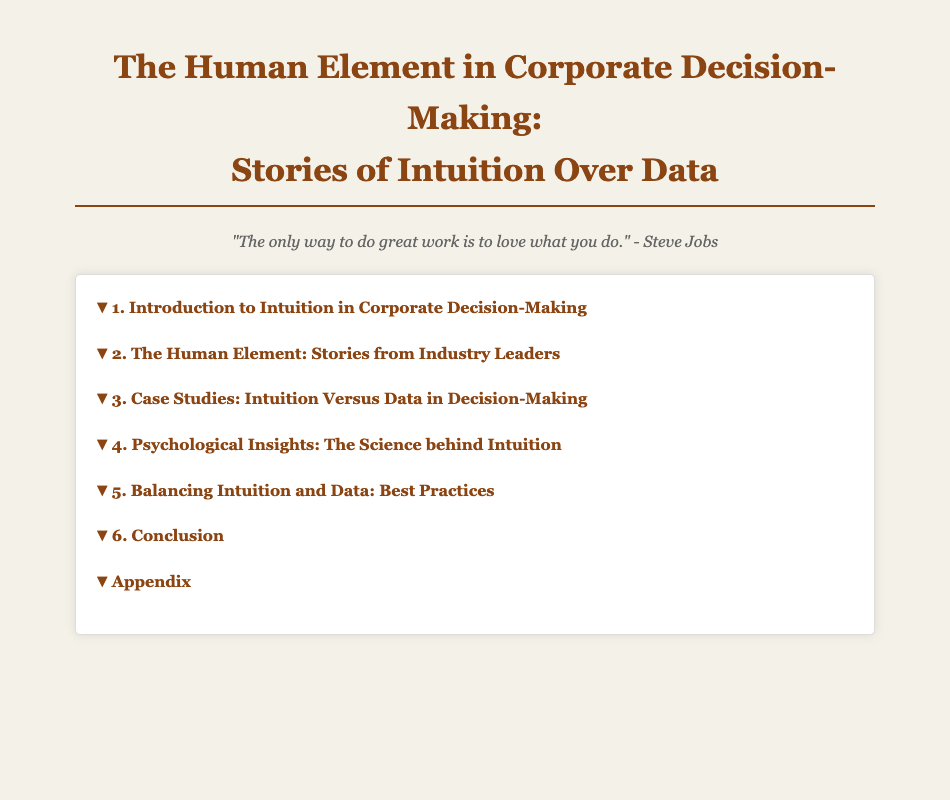What is the title of the document? The title of the document is stated at the top of the Table of Contents.
Answer: The Human Element in Corporate Decision-Making: Stories of Intuition Over Data How many chapters are in the document? The total number of chapters can be counted from the Table of Contents.
Answer: 6 Who is discussed in section 2.1? Section 2.1 mentions a prominent figure in the corporate world.
Answer: Steve Jobs What is the focus of chapter 4? Chapter 4 explores a specific aspect related to decision-making.
Answer: Psychological Insights Which case study is about Ford? A particular case study focuses on a well-known automotive decision.
Answer: Ford's Bet on the Mustang What follows chapter 5? The section that comes after chapter 5 provides a summary and conclusions.
Answer: Conclusion What is the section number for the future of intuitive decision-making? The section on future implications is part of the conclusion.
Answer: 6.2 